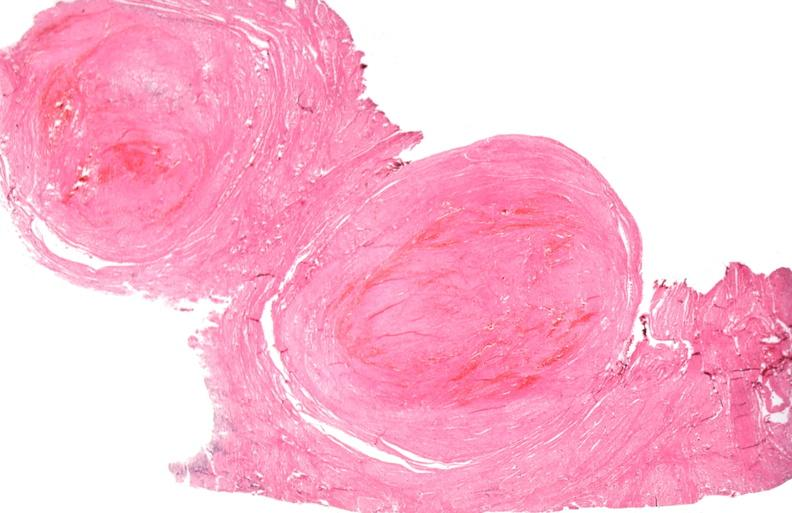s pituitary present?
Answer the question using a single word or phrase. No 